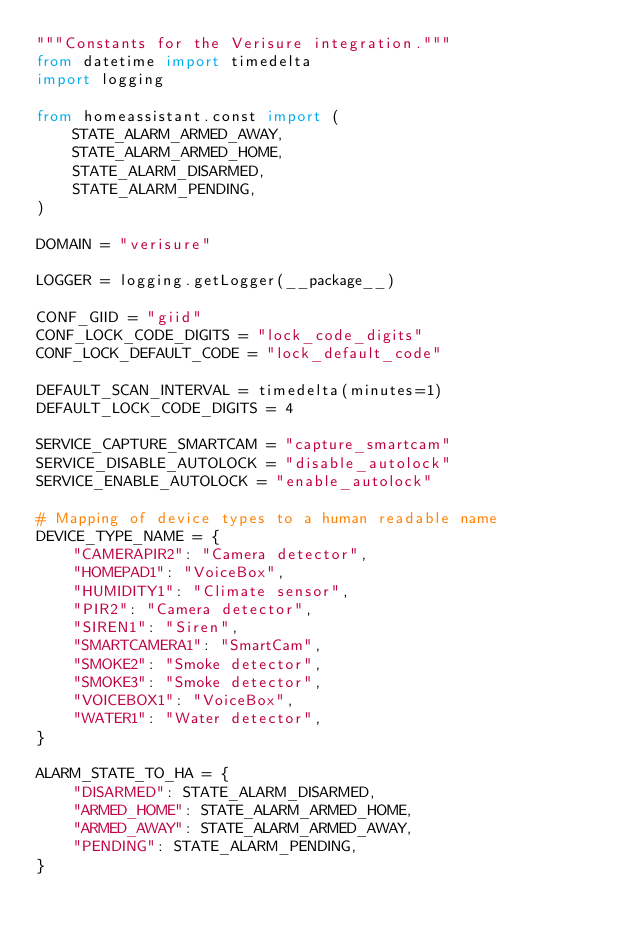Convert code to text. <code><loc_0><loc_0><loc_500><loc_500><_Python_>"""Constants for the Verisure integration."""
from datetime import timedelta
import logging

from homeassistant.const import (
    STATE_ALARM_ARMED_AWAY,
    STATE_ALARM_ARMED_HOME,
    STATE_ALARM_DISARMED,
    STATE_ALARM_PENDING,
)

DOMAIN = "verisure"

LOGGER = logging.getLogger(__package__)

CONF_GIID = "giid"
CONF_LOCK_CODE_DIGITS = "lock_code_digits"
CONF_LOCK_DEFAULT_CODE = "lock_default_code"

DEFAULT_SCAN_INTERVAL = timedelta(minutes=1)
DEFAULT_LOCK_CODE_DIGITS = 4

SERVICE_CAPTURE_SMARTCAM = "capture_smartcam"
SERVICE_DISABLE_AUTOLOCK = "disable_autolock"
SERVICE_ENABLE_AUTOLOCK = "enable_autolock"

# Mapping of device types to a human readable name
DEVICE_TYPE_NAME = {
    "CAMERAPIR2": "Camera detector",
    "HOMEPAD1": "VoiceBox",
    "HUMIDITY1": "Climate sensor",
    "PIR2": "Camera detector",
    "SIREN1": "Siren",
    "SMARTCAMERA1": "SmartCam",
    "SMOKE2": "Smoke detector",
    "SMOKE3": "Smoke detector",
    "VOICEBOX1": "VoiceBox",
    "WATER1": "Water detector",
}

ALARM_STATE_TO_HA = {
    "DISARMED": STATE_ALARM_DISARMED,
    "ARMED_HOME": STATE_ALARM_ARMED_HOME,
    "ARMED_AWAY": STATE_ALARM_ARMED_AWAY,
    "PENDING": STATE_ALARM_PENDING,
}
</code> 